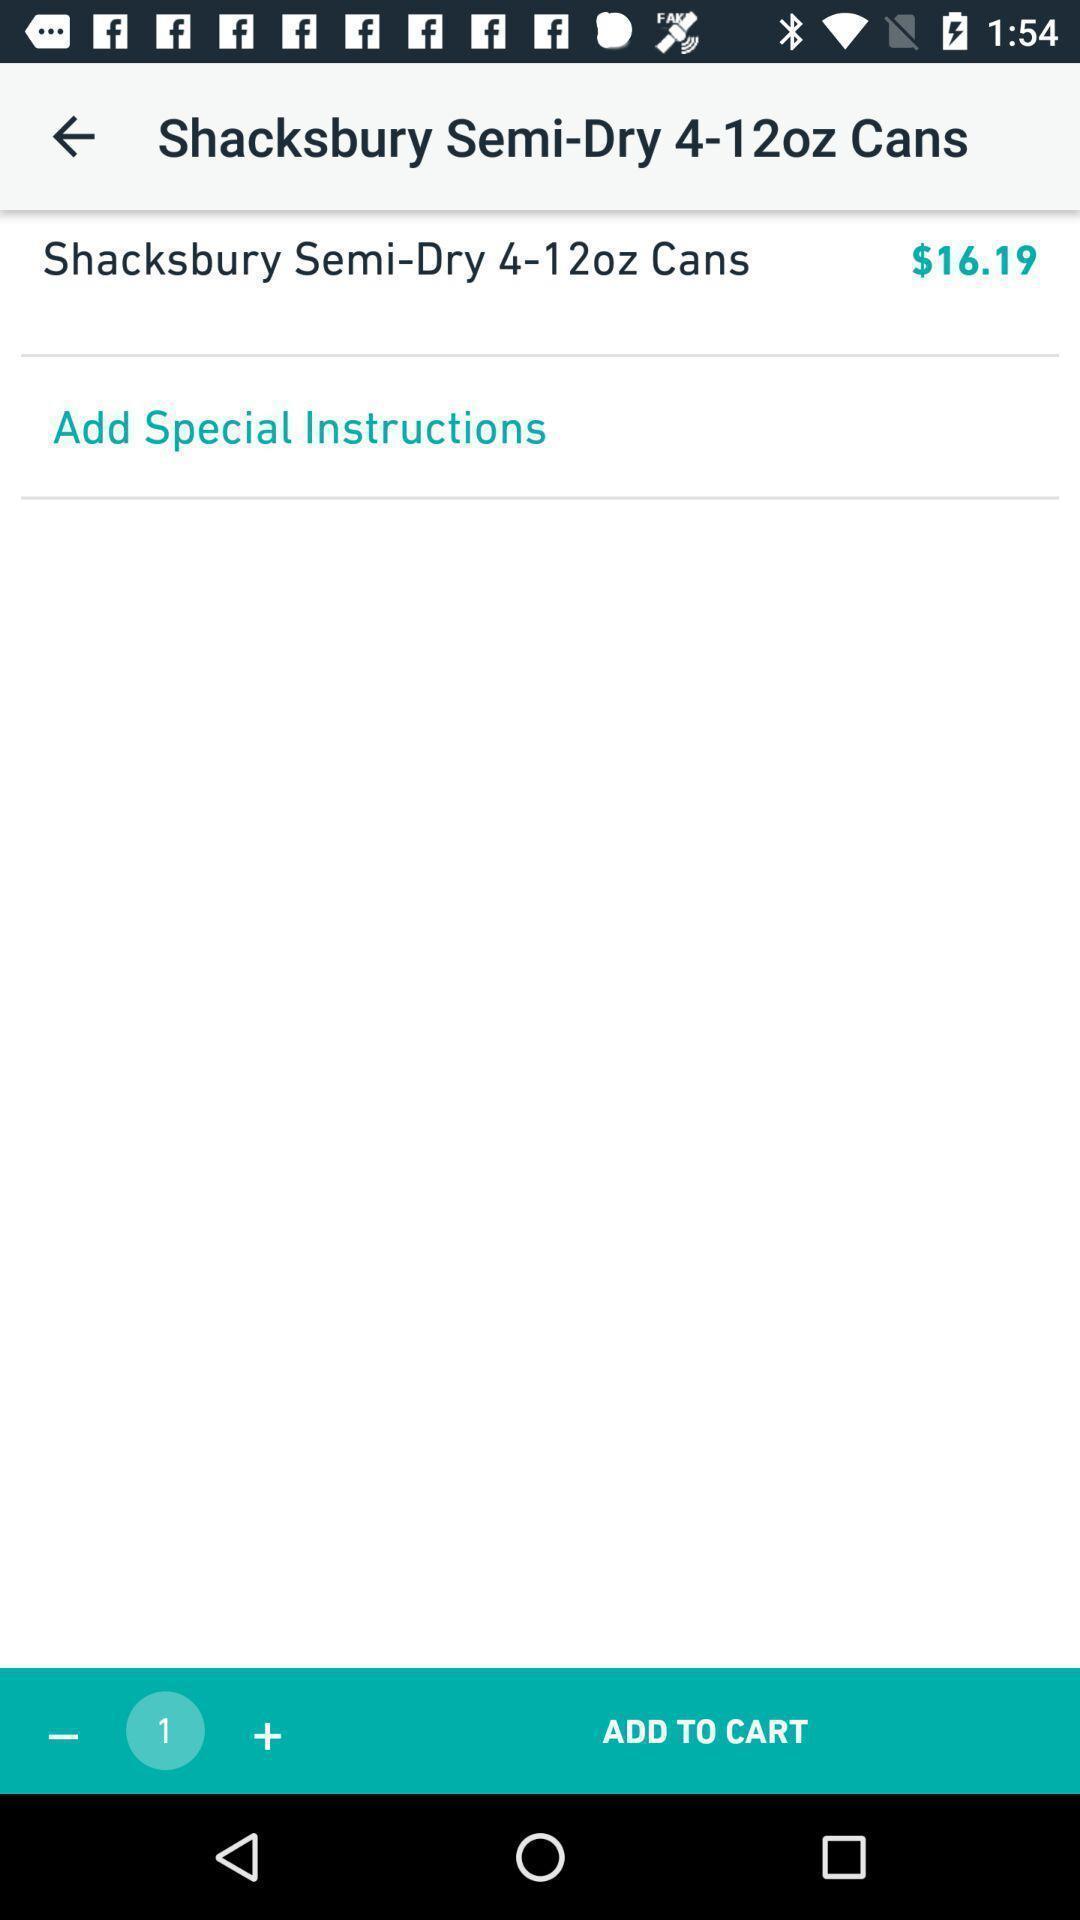Explain the elements present in this screenshot. Page showing different recipes available. 